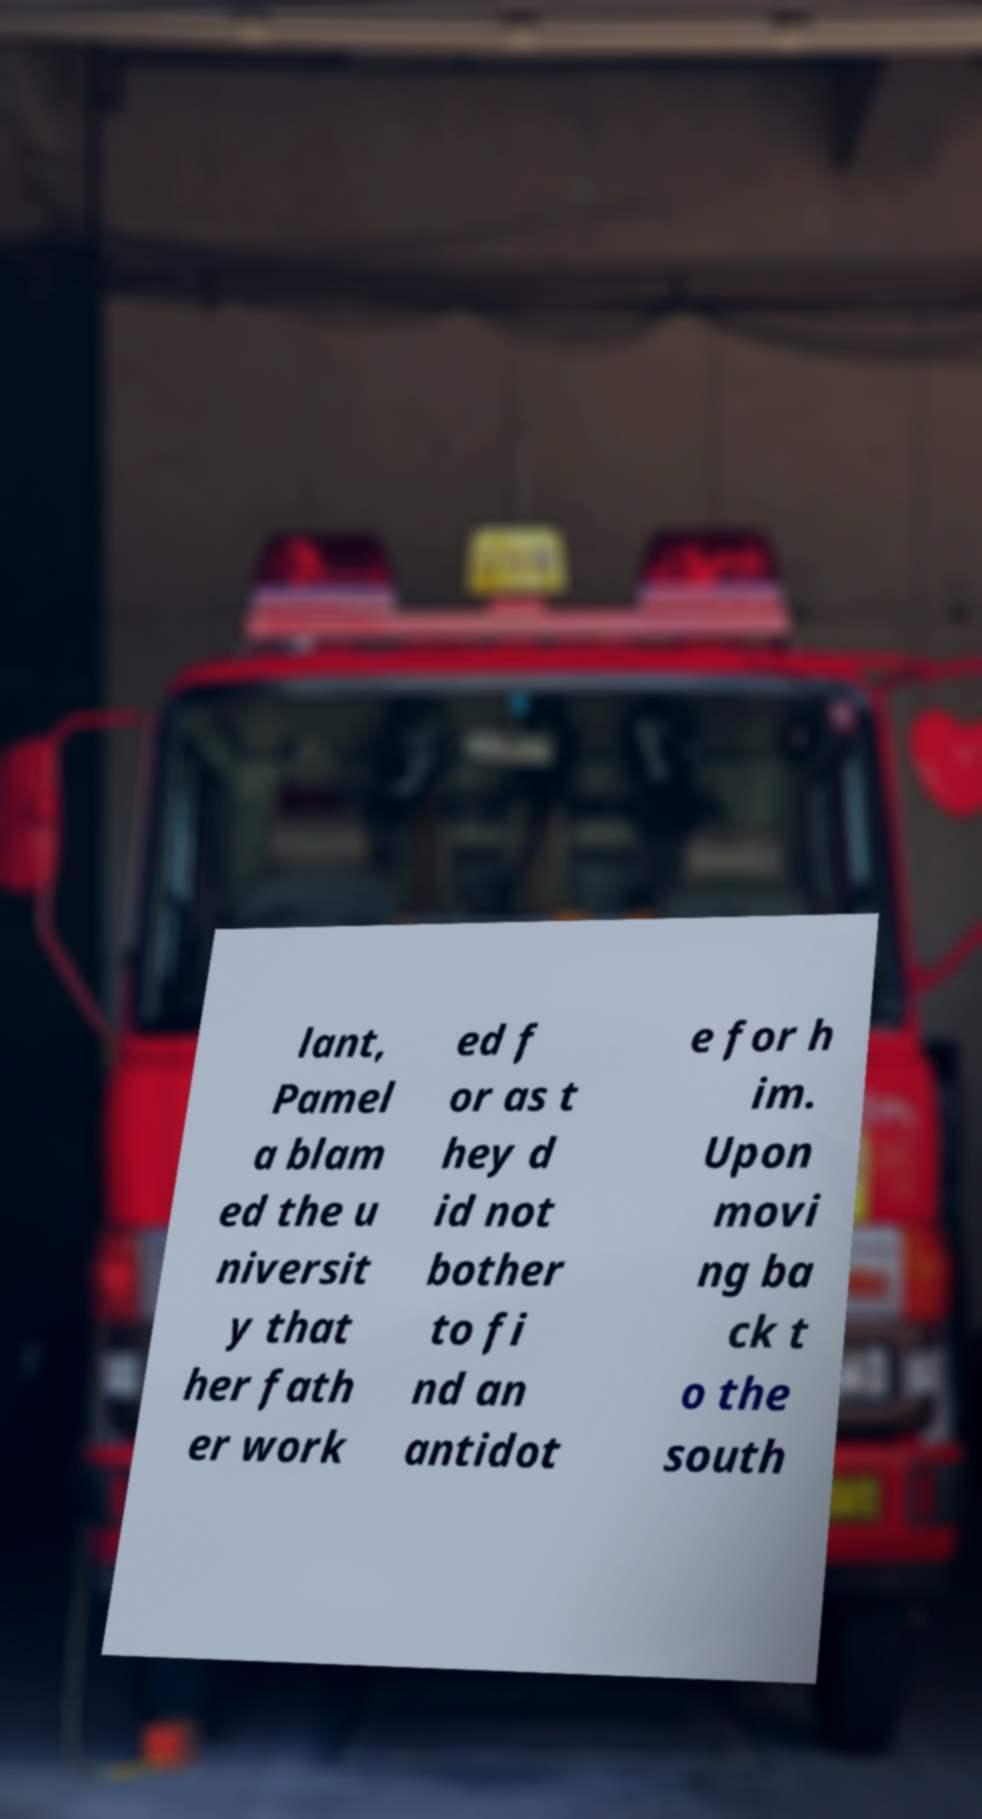Could you extract and type out the text from this image? lant, Pamel a blam ed the u niversit y that her fath er work ed f or as t hey d id not bother to fi nd an antidot e for h im. Upon movi ng ba ck t o the south 